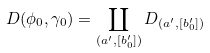Convert formula to latex. <formula><loc_0><loc_0><loc_500><loc_500>D ( \phi _ { 0 } , \gamma _ { 0 } ) = \coprod _ { ( a ^ { \prime } , [ b _ { 0 } ^ { \prime } ] ) } D _ { ( a ^ { \prime } , [ b _ { 0 } ^ { \prime } ] ) }</formula> 